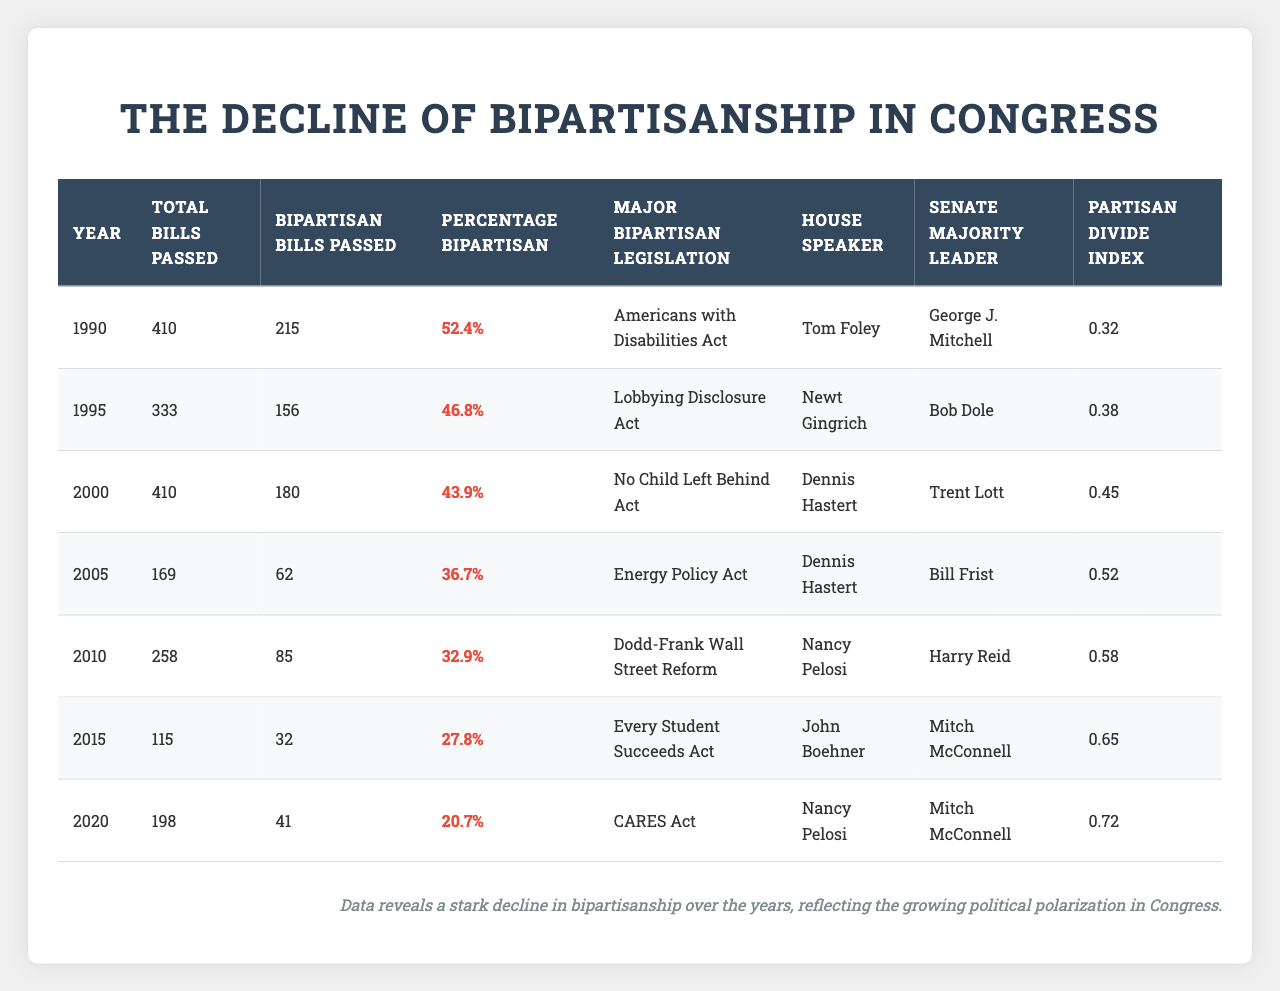What year had the highest number of bipartisan bills passed? By looking at the "Bipartisan Bills Passed" column, 215 bipartisan bills were passed in 1990, which is higher than any other year in the table.
Answer: 1990 What is the percentage of bipartisan bills passed in 2015? The "Percentage Bipartisan" column shows that in 2015, the percentage of bipartisan bills passed was 27.8%.
Answer: 27.8% How many total bills were passed in 2005? The table lists that 169 total bills were passed in 2005, which is directly found in the "Total Bills Passed" column.
Answer: 169 What is the average percentage of bipartisan bills passed from 1990 to 2020? To find the average, sum the percentages from the "Percentage Bipartisan" column (52.4 + 46.8 + 43.9 + 36.7 + 32.9 + 27.8 + 20.7 = 260.2) and divide by 7 (the number of years), so 260.2 / 7 = 37.2%.
Answer: 37.2% Was there a notable decrease in bipartisan bills from 2010 to 2015? In 2010, there were 85 bipartisan bills passed compared to only 32 in 2015, indicating a significant decrease.
Answer: Yes What is the difference in the number of total bills passed between 2000 and 2010? The total bills passed in 2000 were 410, and in 2010 were 258. The difference is 410 - 258 = 152.
Answer: 152 Which year has the lowest percentage of bipartisan bills passed? The lowest percentage is found in 2020, where the percentage of bipartisan bills passed was 20.7%.
Answer: 2020 Looking at the partisan divide index, what trend can be observed from 1990 to 2020? The "Partisan Divide Index" shows a steady increase from 0.32 in 1990 to 0.72 in 2020, indicating growing political polarization over these years.
Answer: Increasing trend Which major bipartisan legislation was passed in 2000? According to the "Major Bipartisan Legislation" column for 2000, the No Child Left Behind Act was the major bipartisan legislation passed that year.
Answer: No Child Left Behind Act How did the number of bipartisan bills passed change from 2005 to 2020? In 2005, 62 bipartisan bills were passed, and in 2020 this dropped to 41. The change reflects a decrease of 21 bipartisan bills.
Answer: Decreased by 21 